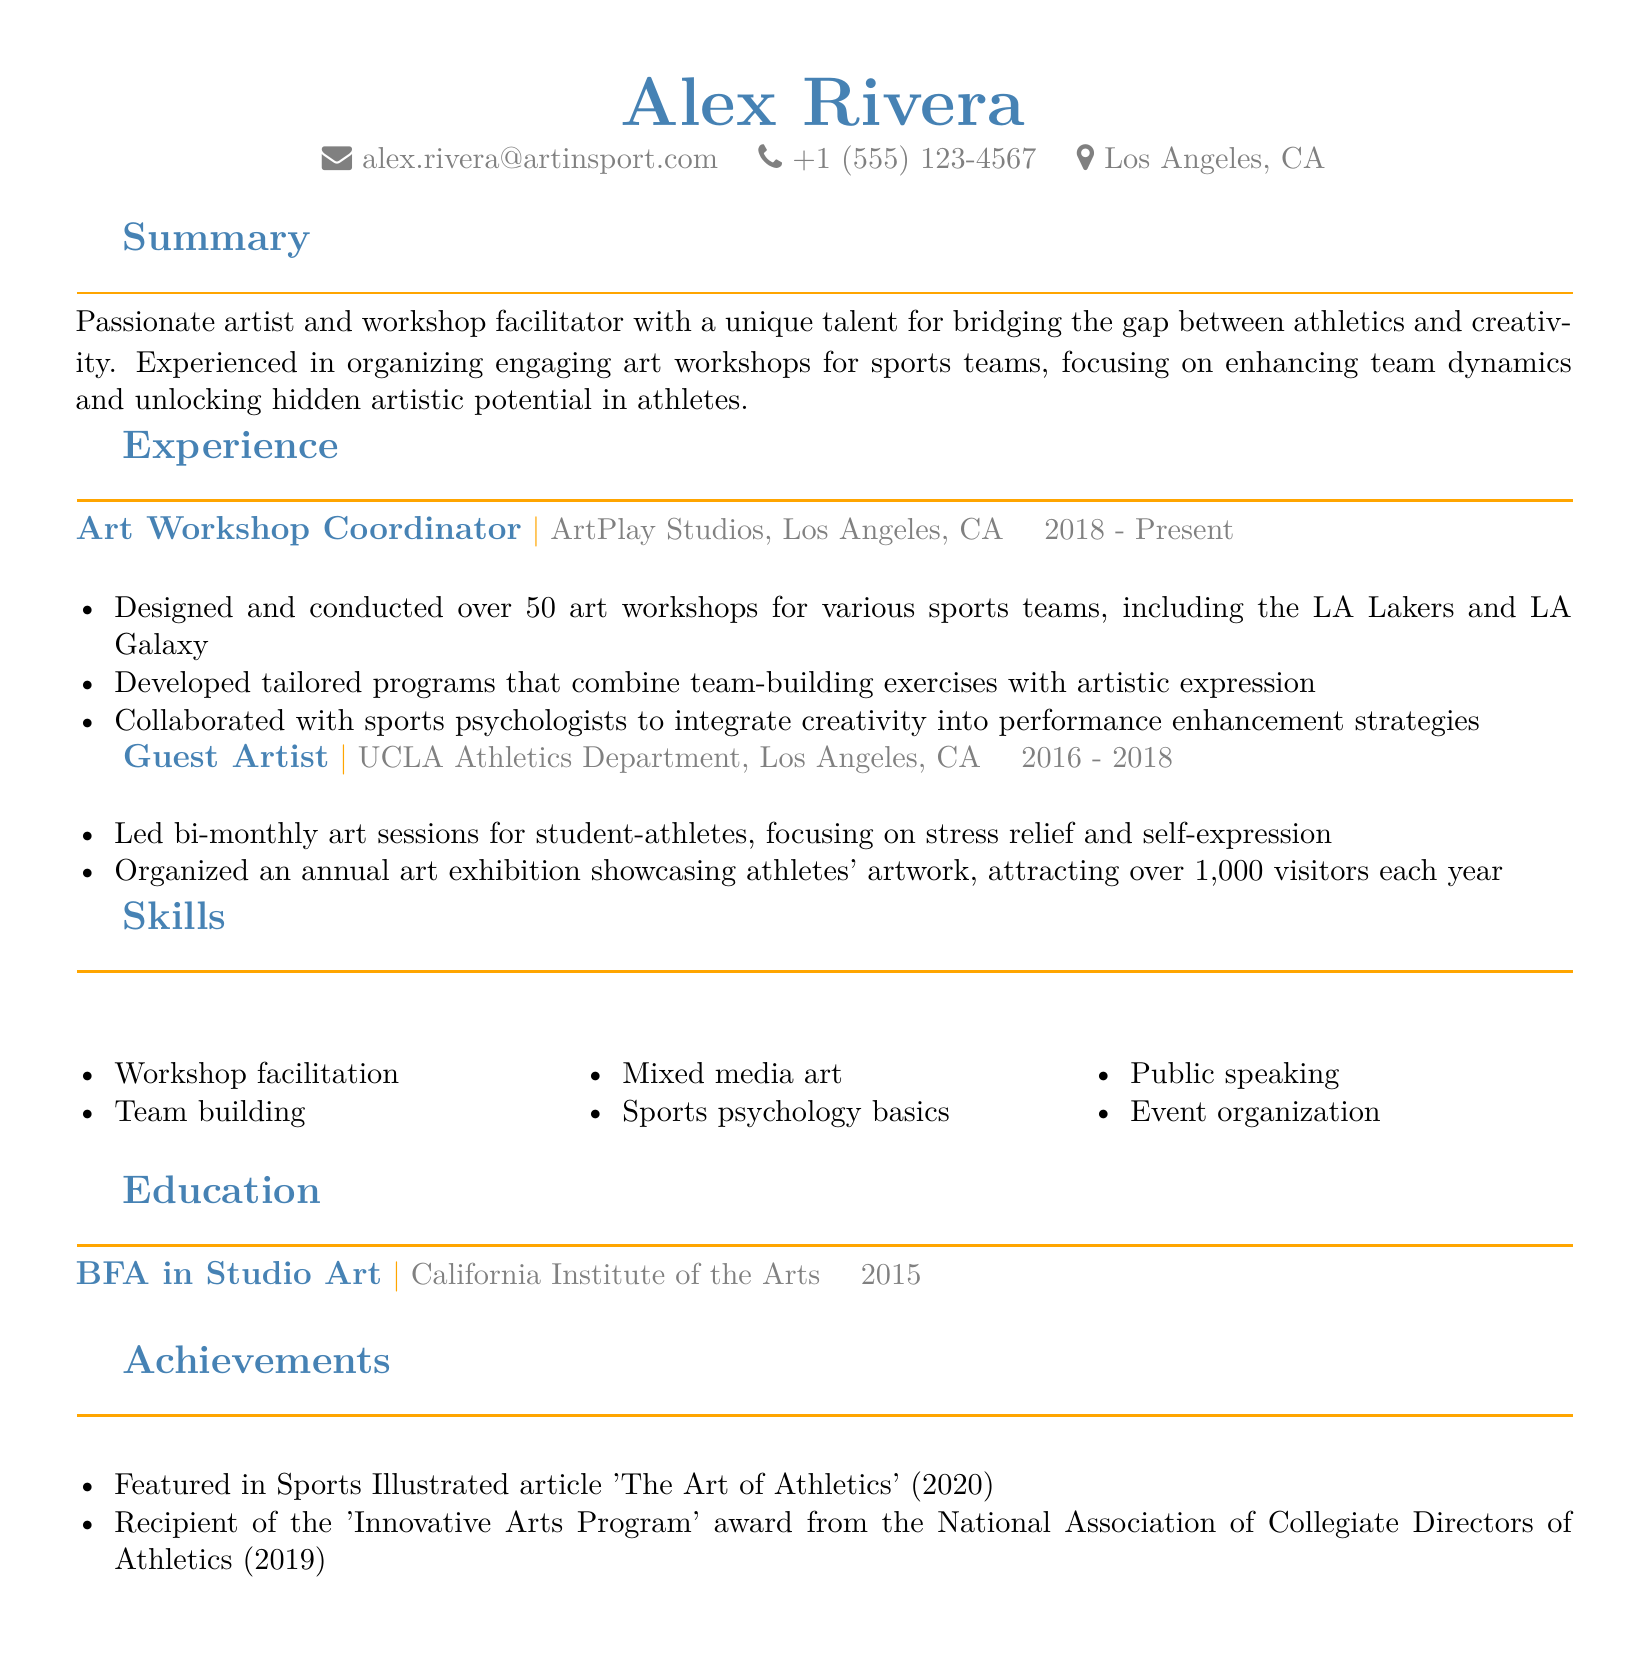What is the name of the artist? The name of the artist is mentioned at the top of the CV.
Answer: Alex Rivera What is the email address provided? The email address is one of the personal details listed in the document.
Answer: alex.rivera@artinsport.com Which company does Alex work for currently? The current company of employment is listed in the experience section.
Answer: ArtPlay Studios What year did Alex graduate? The graduation year is a part of the education details in the document.
Answer: 2015 How many art workshops has Alex conducted? The number of art workshops conducted is specified under responsibilities in the work experience.
Answer: Over 50 What award did Alex receive in 2019? The achievements section highlights the awards received, specifying the year and title.
Answer: 'Innovative Arts Program' What is a focus of the art workshops? This information is derived from the summary and experience sections discussing the workshops.
Answer: Team dynamics and creativity Which sports teams did Alex work with? The sports teams mentioned serve as examples in the work experience section.
Answer: LA Lakers and LA Galaxy How long did Alex work as a Guest Artist? The duration of the role is specified in the experience section.
Answer: 2016 - 2018 